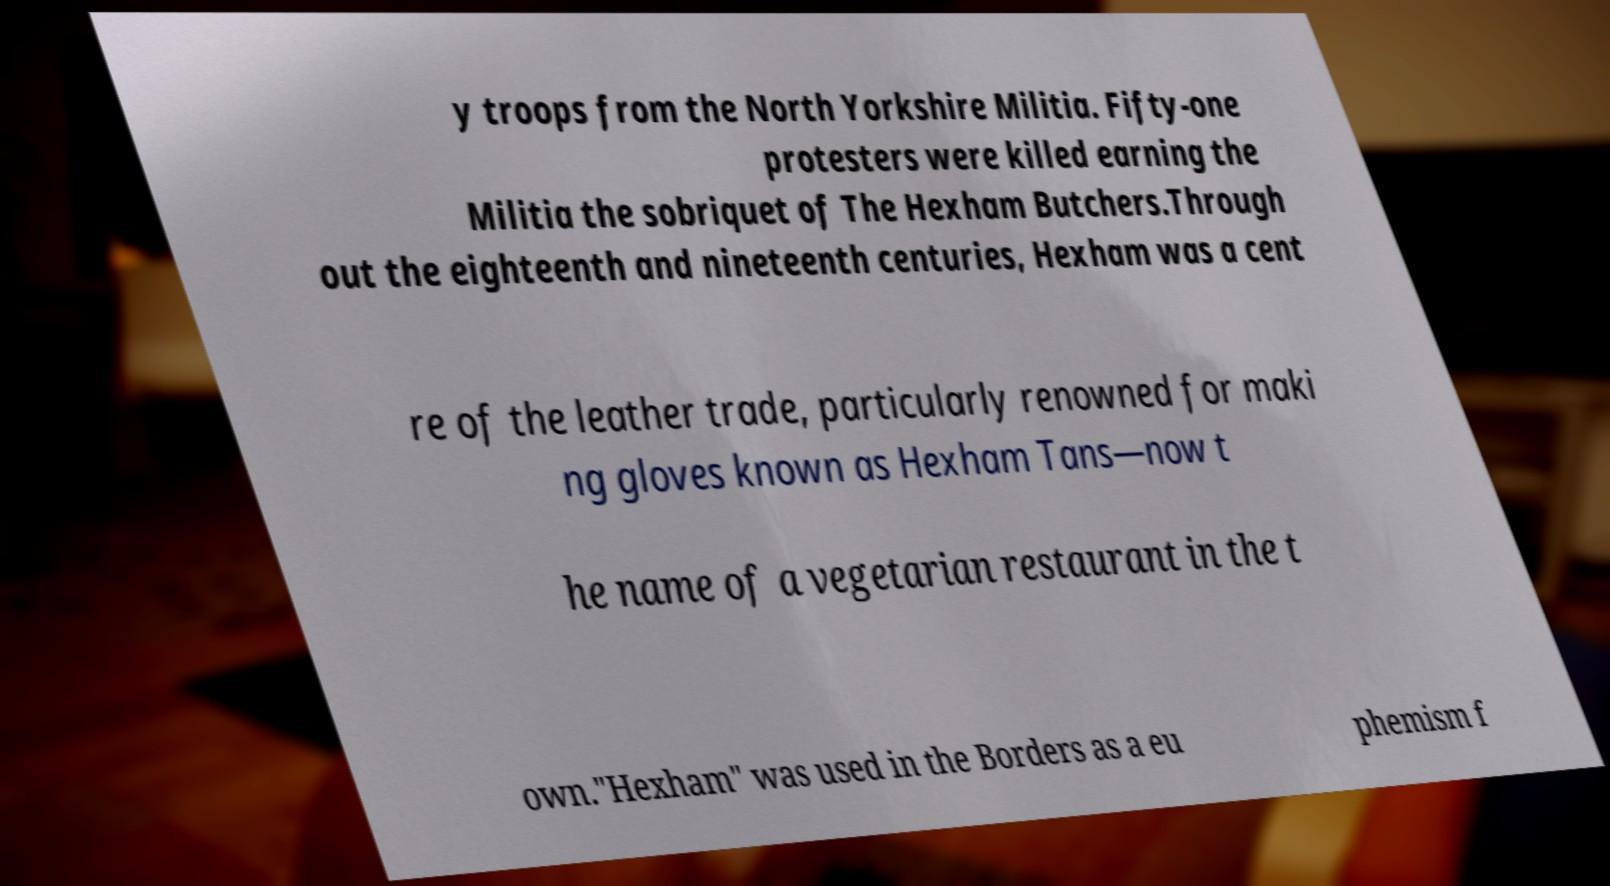Could you extract and type out the text from this image? y troops from the North Yorkshire Militia. Fifty-one protesters were killed earning the Militia the sobriquet of The Hexham Butchers.Through out the eighteenth and nineteenth centuries, Hexham was a cent re of the leather trade, particularly renowned for maki ng gloves known as Hexham Tans—now t he name of a vegetarian restaurant in the t own."Hexham" was used in the Borders as a eu phemism f 